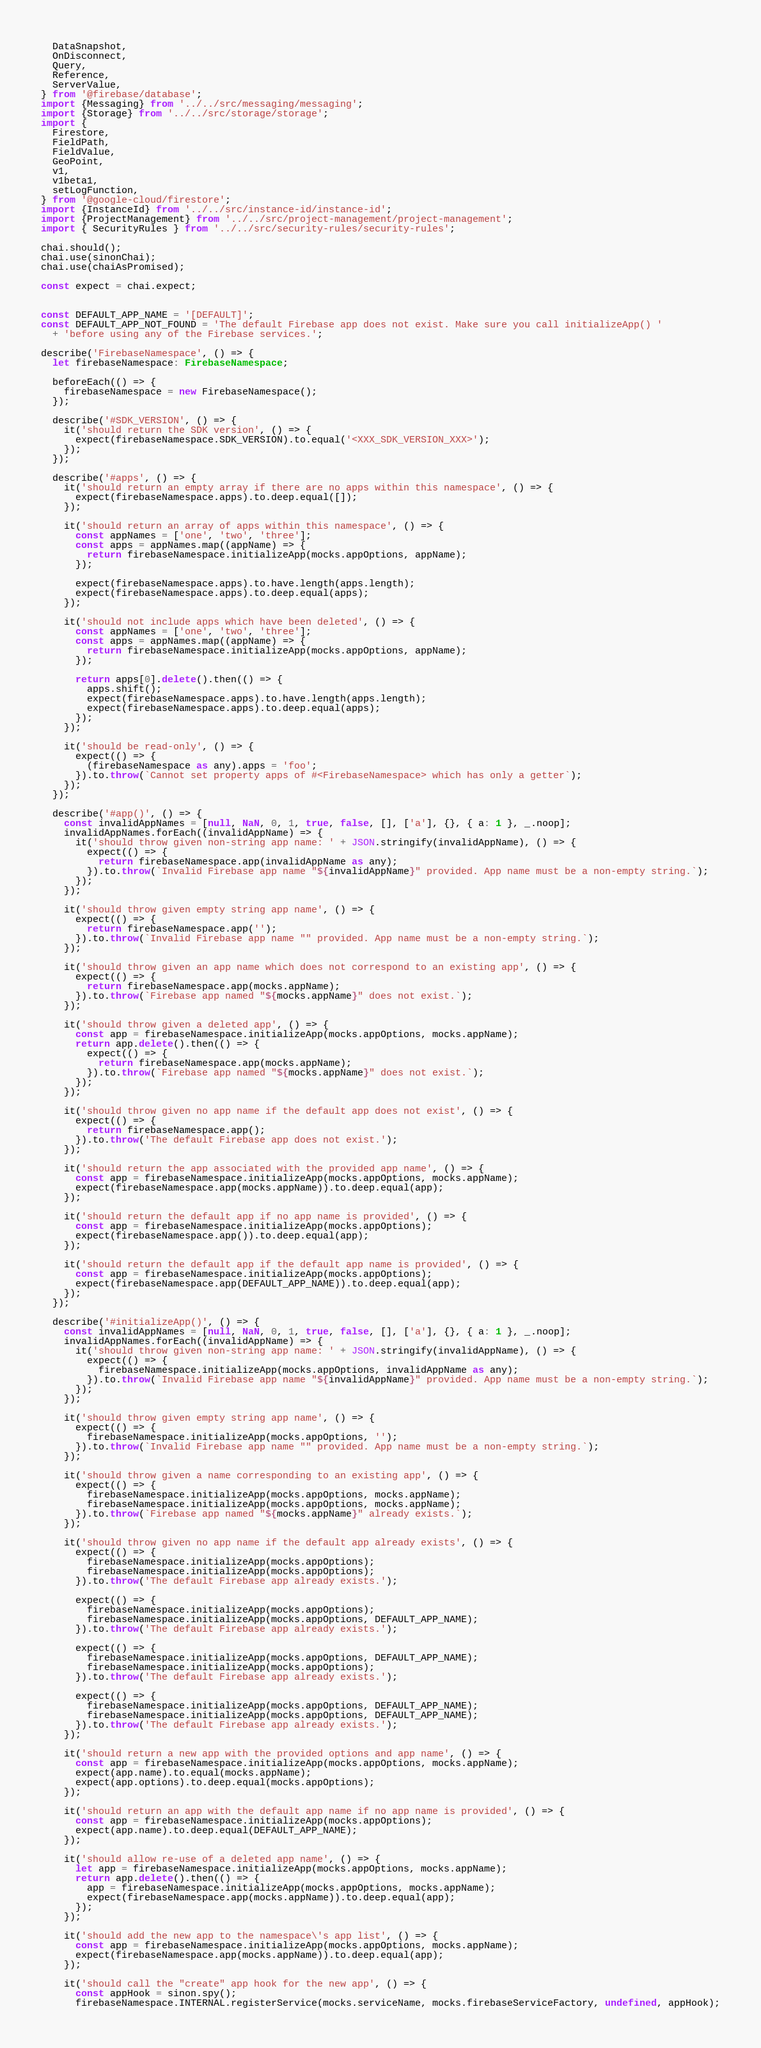Convert code to text. <code><loc_0><loc_0><loc_500><loc_500><_TypeScript_>  DataSnapshot,
  OnDisconnect,
  Query,
  Reference,
  ServerValue,
} from '@firebase/database';
import {Messaging} from '../../src/messaging/messaging';
import {Storage} from '../../src/storage/storage';
import {
  Firestore,
  FieldPath,
  FieldValue,
  GeoPoint,
  v1,
  v1beta1,
  setLogFunction,
} from '@google-cloud/firestore';
import {InstanceId} from '../../src/instance-id/instance-id';
import {ProjectManagement} from '../../src/project-management/project-management';
import { SecurityRules } from '../../src/security-rules/security-rules';

chai.should();
chai.use(sinonChai);
chai.use(chaiAsPromised);

const expect = chai.expect;


const DEFAULT_APP_NAME = '[DEFAULT]';
const DEFAULT_APP_NOT_FOUND = 'The default Firebase app does not exist. Make sure you call initializeApp() '
  + 'before using any of the Firebase services.';

describe('FirebaseNamespace', () => {
  let firebaseNamespace: FirebaseNamespace;

  beforeEach(() => {
    firebaseNamespace = new FirebaseNamespace();
  });

  describe('#SDK_VERSION', () => {
    it('should return the SDK version', () => {
      expect(firebaseNamespace.SDK_VERSION).to.equal('<XXX_SDK_VERSION_XXX>');
    });
  });

  describe('#apps', () => {
    it('should return an empty array if there are no apps within this namespace', () => {
      expect(firebaseNamespace.apps).to.deep.equal([]);
    });

    it('should return an array of apps within this namespace', () => {
      const appNames = ['one', 'two', 'three'];
      const apps = appNames.map((appName) => {
        return firebaseNamespace.initializeApp(mocks.appOptions, appName);
      });

      expect(firebaseNamespace.apps).to.have.length(apps.length);
      expect(firebaseNamespace.apps).to.deep.equal(apps);
    });

    it('should not include apps which have been deleted', () => {
      const appNames = ['one', 'two', 'three'];
      const apps = appNames.map((appName) => {
        return firebaseNamespace.initializeApp(mocks.appOptions, appName);
      });

      return apps[0].delete().then(() => {
        apps.shift();
        expect(firebaseNamespace.apps).to.have.length(apps.length);
        expect(firebaseNamespace.apps).to.deep.equal(apps);
      });
    });

    it('should be read-only', () => {
      expect(() => {
        (firebaseNamespace as any).apps = 'foo';
      }).to.throw(`Cannot set property apps of #<FirebaseNamespace> which has only a getter`);
    });
  });

  describe('#app()', () => {
    const invalidAppNames = [null, NaN, 0, 1, true, false, [], ['a'], {}, { a: 1 }, _.noop];
    invalidAppNames.forEach((invalidAppName) => {
      it('should throw given non-string app name: ' + JSON.stringify(invalidAppName), () => {
        expect(() => {
          return firebaseNamespace.app(invalidAppName as any);
        }).to.throw(`Invalid Firebase app name "${invalidAppName}" provided. App name must be a non-empty string.`);
      });
    });

    it('should throw given empty string app name', () => {
      expect(() => {
        return firebaseNamespace.app('');
      }).to.throw(`Invalid Firebase app name "" provided. App name must be a non-empty string.`);
    });

    it('should throw given an app name which does not correspond to an existing app', () => {
      expect(() => {
        return firebaseNamespace.app(mocks.appName);
      }).to.throw(`Firebase app named "${mocks.appName}" does not exist.`);
    });

    it('should throw given a deleted app', () => {
      const app = firebaseNamespace.initializeApp(mocks.appOptions, mocks.appName);
      return app.delete().then(() => {
        expect(() => {
          return firebaseNamespace.app(mocks.appName);
        }).to.throw(`Firebase app named "${mocks.appName}" does not exist.`);
      });
    });

    it('should throw given no app name if the default app does not exist', () => {
      expect(() => {
        return firebaseNamespace.app();
      }).to.throw('The default Firebase app does not exist.');
    });

    it('should return the app associated with the provided app name', () => {
      const app = firebaseNamespace.initializeApp(mocks.appOptions, mocks.appName);
      expect(firebaseNamespace.app(mocks.appName)).to.deep.equal(app);
    });

    it('should return the default app if no app name is provided', () => {
      const app = firebaseNamespace.initializeApp(mocks.appOptions);
      expect(firebaseNamespace.app()).to.deep.equal(app);
    });

    it('should return the default app if the default app name is provided', () => {
      const app = firebaseNamespace.initializeApp(mocks.appOptions);
      expect(firebaseNamespace.app(DEFAULT_APP_NAME)).to.deep.equal(app);
    });
  });

  describe('#initializeApp()', () => {
    const invalidAppNames = [null, NaN, 0, 1, true, false, [], ['a'], {}, { a: 1 }, _.noop];
    invalidAppNames.forEach((invalidAppName) => {
      it('should throw given non-string app name: ' + JSON.stringify(invalidAppName), () => {
        expect(() => {
          firebaseNamespace.initializeApp(mocks.appOptions, invalidAppName as any);
        }).to.throw(`Invalid Firebase app name "${invalidAppName}" provided. App name must be a non-empty string.`);
      });
    });

    it('should throw given empty string app name', () => {
      expect(() => {
        firebaseNamespace.initializeApp(mocks.appOptions, '');
      }).to.throw(`Invalid Firebase app name "" provided. App name must be a non-empty string.`);
    });

    it('should throw given a name corresponding to an existing app', () => {
      expect(() => {
        firebaseNamespace.initializeApp(mocks.appOptions, mocks.appName);
        firebaseNamespace.initializeApp(mocks.appOptions, mocks.appName);
      }).to.throw(`Firebase app named "${mocks.appName}" already exists.`);
    });

    it('should throw given no app name if the default app already exists', () => {
      expect(() => {
        firebaseNamespace.initializeApp(mocks.appOptions);
        firebaseNamespace.initializeApp(mocks.appOptions);
      }).to.throw('The default Firebase app already exists.');

      expect(() => {
        firebaseNamespace.initializeApp(mocks.appOptions);
        firebaseNamespace.initializeApp(mocks.appOptions, DEFAULT_APP_NAME);
      }).to.throw('The default Firebase app already exists.');

      expect(() => {
        firebaseNamespace.initializeApp(mocks.appOptions, DEFAULT_APP_NAME);
        firebaseNamespace.initializeApp(mocks.appOptions);
      }).to.throw('The default Firebase app already exists.');

      expect(() => {
        firebaseNamespace.initializeApp(mocks.appOptions, DEFAULT_APP_NAME);
        firebaseNamespace.initializeApp(mocks.appOptions, DEFAULT_APP_NAME);
      }).to.throw('The default Firebase app already exists.');
    });

    it('should return a new app with the provided options and app name', () => {
      const app = firebaseNamespace.initializeApp(mocks.appOptions, mocks.appName);
      expect(app.name).to.equal(mocks.appName);
      expect(app.options).to.deep.equal(mocks.appOptions);
    });

    it('should return an app with the default app name if no app name is provided', () => {
      const app = firebaseNamespace.initializeApp(mocks.appOptions);
      expect(app.name).to.deep.equal(DEFAULT_APP_NAME);
    });

    it('should allow re-use of a deleted app name', () => {
      let app = firebaseNamespace.initializeApp(mocks.appOptions, mocks.appName);
      return app.delete().then(() => {
        app = firebaseNamespace.initializeApp(mocks.appOptions, mocks.appName);
        expect(firebaseNamespace.app(mocks.appName)).to.deep.equal(app);
      });
    });

    it('should add the new app to the namespace\'s app list', () => {
      const app = firebaseNamespace.initializeApp(mocks.appOptions, mocks.appName);
      expect(firebaseNamespace.app(mocks.appName)).to.deep.equal(app);
    });

    it('should call the "create" app hook for the new app', () => {
      const appHook = sinon.spy();
      firebaseNamespace.INTERNAL.registerService(mocks.serviceName, mocks.firebaseServiceFactory, undefined, appHook);
</code> 